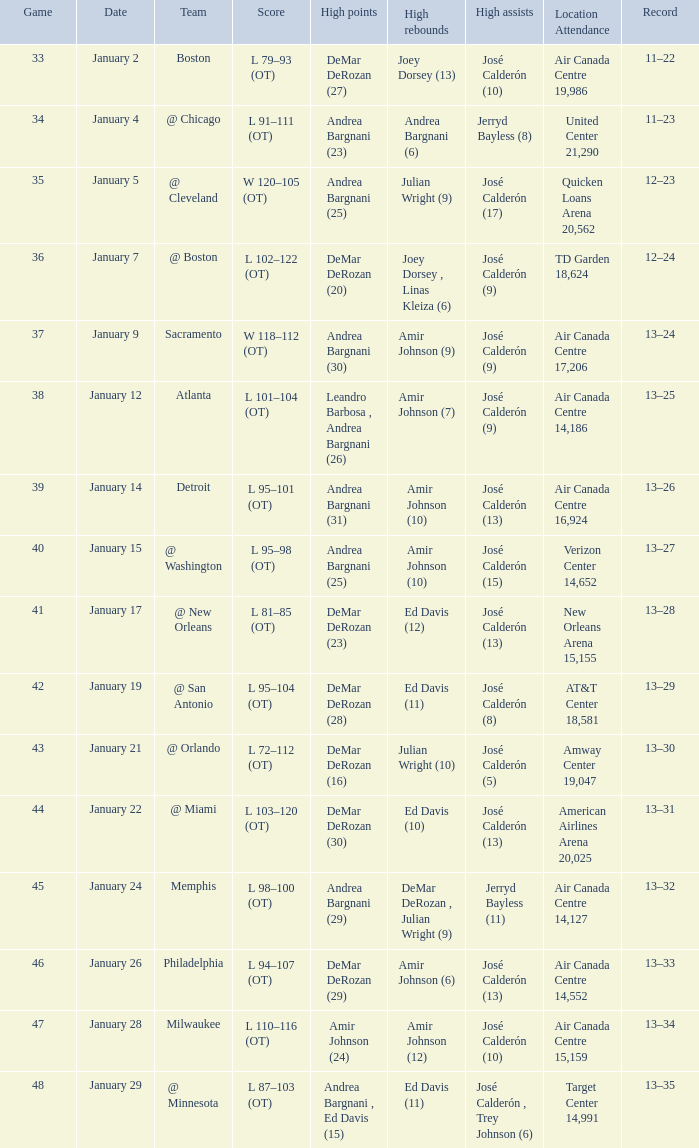Name the number of high rebounds for january 5 1.0. 